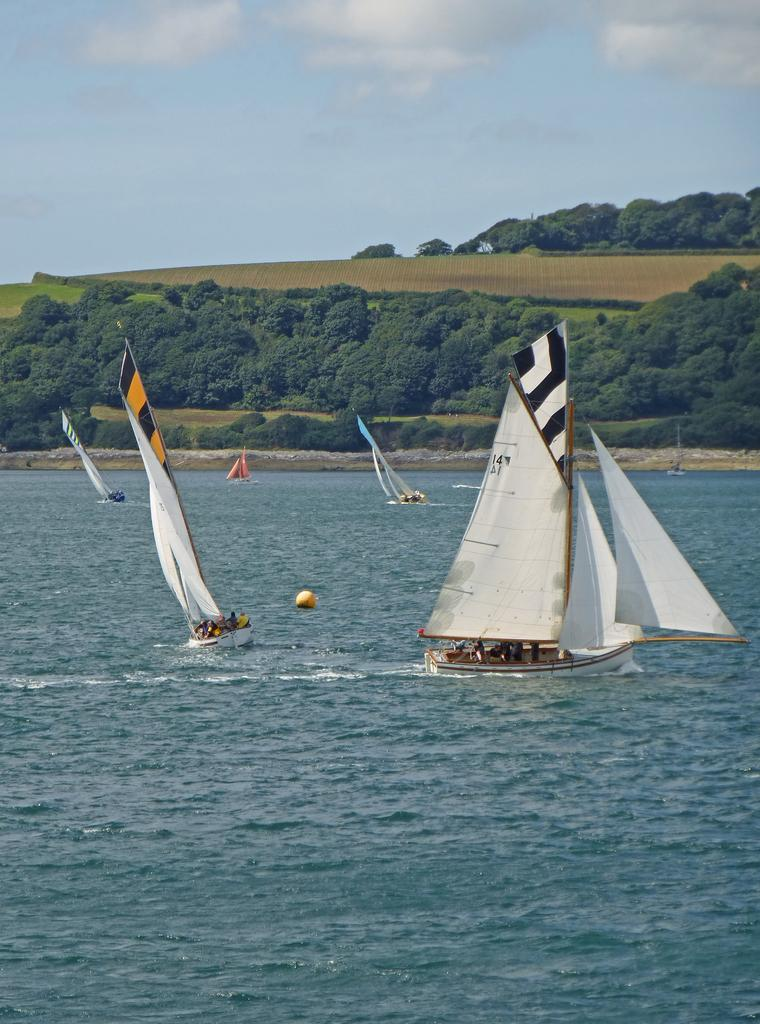What is on the water in the image? There are boats on the water in the image. Who or what is in the boats? There are people in the boats. What can be seen in the background of the image? There are trees and clouds visible in the background of the image. How many pigs are swimming in the water next to the boats? There are no pigs visible in the image; only boats and people are present. What type of sponge is being used by the people in the boats? There is no sponge visible in the image, and it is not mentioned that the people are using any sponges. 